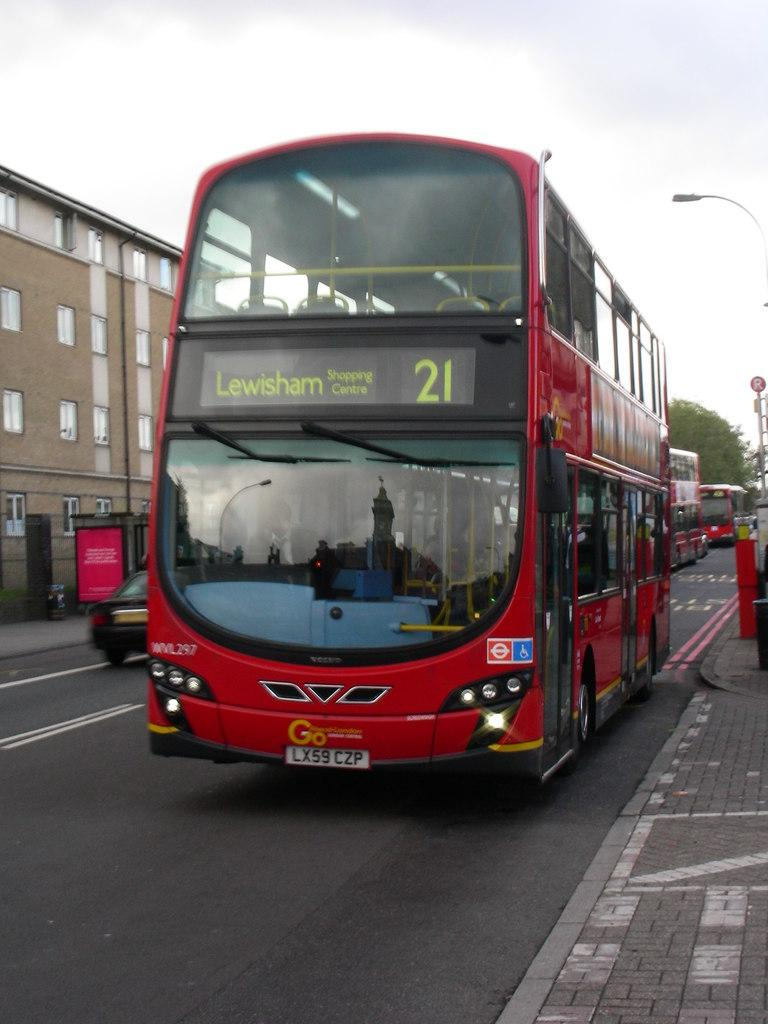Provide a one-sentence caption for the provided image. Bus number 21 is heading the the Lewisham shopping centre. 